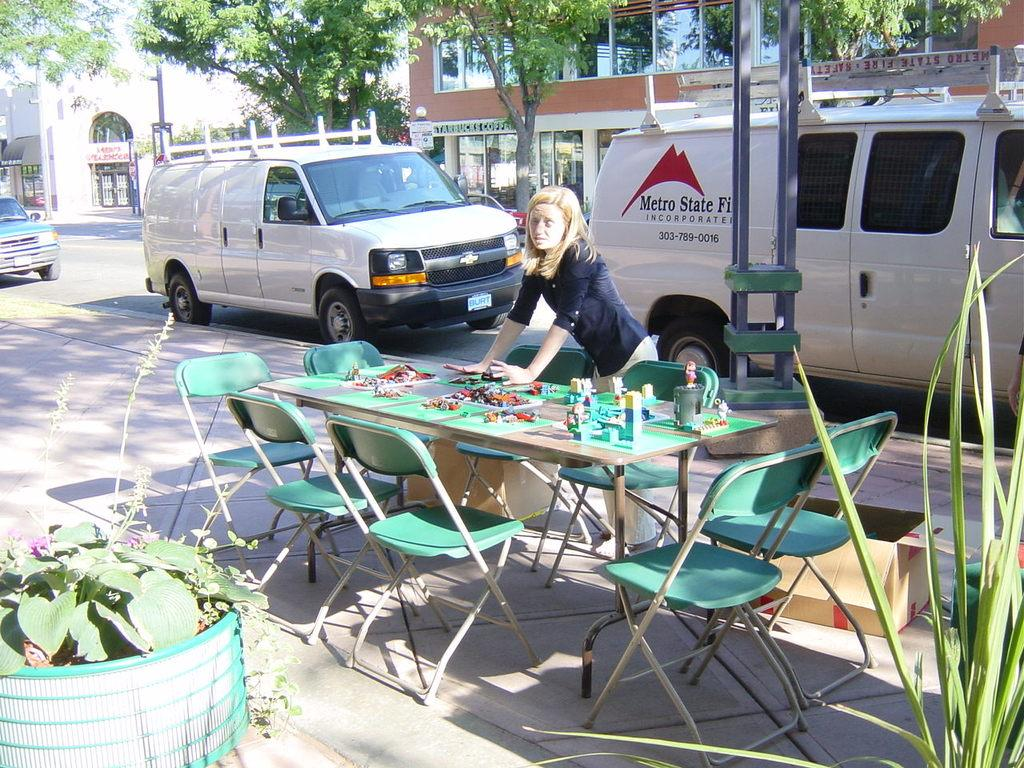<image>
Provide a brief description of the given image. A woman stands in front of a van that says Metro State. 